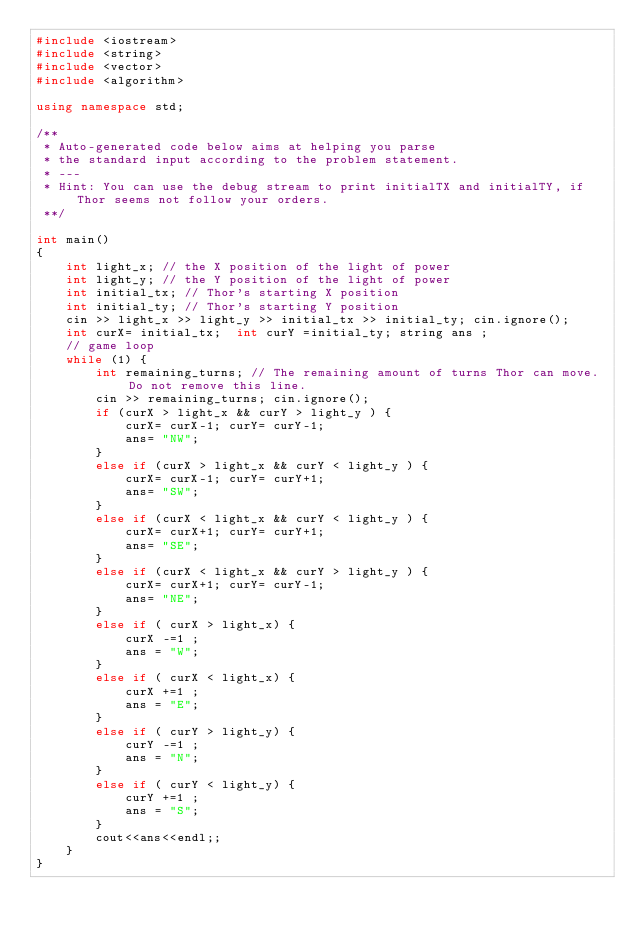Convert code to text. <code><loc_0><loc_0><loc_500><loc_500><_C++_>#include <iostream>
#include <string>
#include <vector>
#include <algorithm>

using namespace std;

/**
 * Auto-generated code below aims at helping you parse
 * the standard input according to the problem statement.
 * ---
 * Hint: You can use the debug stream to print initialTX and initialTY, if Thor seems not follow your orders.
 **/

int main()
{
    int light_x; // the X position of the light of power
    int light_y; // the Y position of the light of power
    int initial_tx; // Thor's starting X position
    int initial_ty; // Thor's starting Y position
    cin >> light_x >> light_y >> initial_tx >> initial_ty; cin.ignore();
    int curX= initial_tx;  int curY =initial_ty; string ans ; 
    // game loop
    while (1) {
        int remaining_turns; // The remaining amount of turns Thor can move. Do not remove this line.
        cin >> remaining_turns; cin.ignore();
        if (curX > light_x && curY > light_y ) {  
            curX= curX-1; curY= curY-1; 
            ans= "NW"; 
        }
        else if (curX > light_x && curY < light_y ) {  
            curX= curX-1; curY= curY+1; 
            ans= "SW"; 
        }
        else if (curX < light_x && curY < light_y ) {  
            curX= curX+1; curY= curY+1; 
            ans= "SE"; 
        }
        else if (curX < light_x && curY > light_y ) {  
            curX= curX+1; curY= curY-1; 
            ans= "NE"; 
        }
        else if ( curX > light_x) { 
            curX -=1 ; 
            ans = "W";
        }
        else if ( curX < light_x) { 
            curX +=1 ; 
            ans = "E";
        }
        else if ( curY > light_y) { 
            curY -=1 ; 
            ans = "N";
        }
        else if ( curY < light_y) { 
            curY +=1 ; 
            ans = "S";
        }
        cout<<ans<<endl;; 
    }
}
</code> 